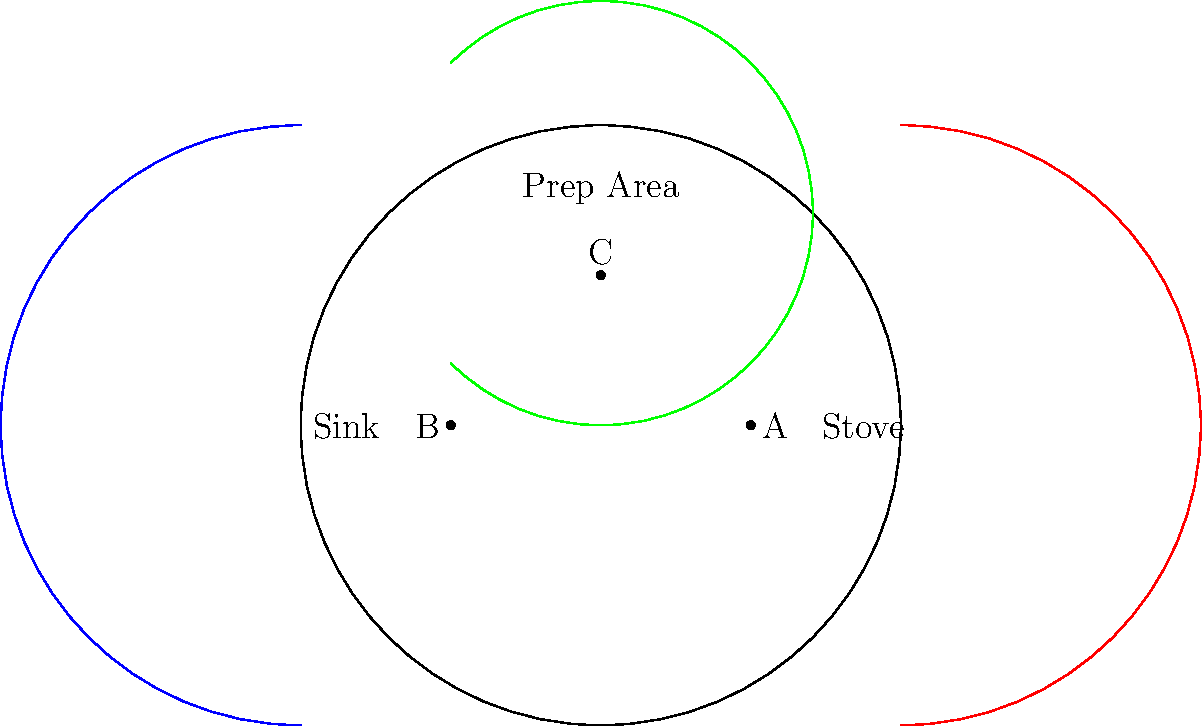In a circular kitchen design based on the Poincaré disk model, three key areas are positioned: a stove (A), a sink (B), and a prep area (C). The blue, red, and green arcs represent the optimal paths between these areas. Which path represents the shortest distance in this non-Euclidean space, and why is this significant for kitchen workflow efficiency? To understand the shortest path in the Poincaré disk model, we need to follow these steps:

1. In the Poincaré disk model, straight lines are represented by arcs that intersect the boundary circle perpendicularly.

2. The blue arc connects B (sink) and C (prep area), the red arc connects A (stove) and C (prep area), and the green arc connects A (stove) and B (sink).

3. In this model, the shortest distance between two points is represented by the arc that intersects the boundary circle at right angles.

4. Observing the diagram, we can see that the green arc has the smallest curvature and appears to be the closest to a straight line in Euclidean geometry.

5. The green arc represents the path between the stove (A) and the sink (B), which are positioned on opposite sides of the circular kitchen.

6. In non-Euclidean geometry, this arc is the geodesic (shortest path) between these two points.

7. For kitchen workflow efficiency, this means that the stove and sink are optimally positioned relative to each other, minimizing the distance a chef needs to travel between these two crucial areas.

8. The prep area (C) is positioned such that it forms equidistant paths to both the stove and the sink, allowing for efficient movement between all three key areas.

This non-Euclidean approach to kitchen design allows for maximizing space utilization and workflow efficiency in a circular kitchen layout, which could be particularly useful in compact or uniquely shaped restaurant kitchens.
Answer: The green arc (stove to sink) is shortest, optimizing workflow between key areas. 